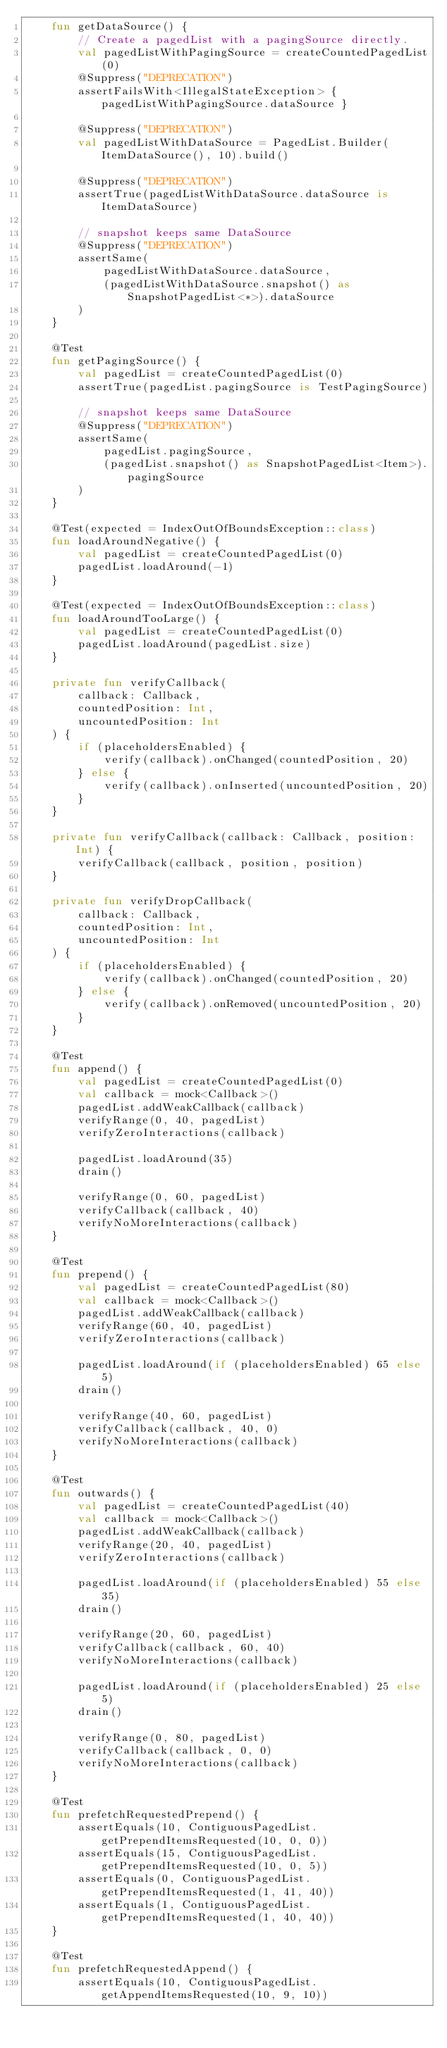<code> <loc_0><loc_0><loc_500><loc_500><_Kotlin_>    fun getDataSource() {
        // Create a pagedList with a pagingSource directly.
        val pagedListWithPagingSource = createCountedPagedList(0)
        @Suppress("DEPRECATION")
        assertFailsWith<IllegalStateException> { pagedListWithPagingSource.dataSource }

        @Suppress("DEPRECATION")
        val pagedListWithDataSource = PagedList.Builder(ItemDataSource(), 10).build()

        @Suppress("DEPRECATION")
        assertTrue(pagedListWithDataSource.dataSource is ItemDataSource)

        // snapshot keeps same DataSource
        @Suppress("DEPRECATION")
        assertSame(
            pagedListWithDataSource.dataSource,
            (pagedListWithDataSource.snapshot() as SnapshotPagedList<*>).dataSource
        )
    }

    @Test
    fun getPagingSource() {
        val pagedList = createCountedPagedList(0)
        assertTrue(pagedList.pagingSource is TestPagingSource)

        // snapshot keeps same DataSource
        @Suppress("DEPRECATION")
        assertSame(
            pagedList.pagingSource,
            (pagedList.snapshot() as SnapshotPagedList<Item>).pagingSource
        )
    }

    @Test(expected = IndexOutOfBoundsException::class)
    fun loadAroundNegative() {
        val pagedList = createCountedPagedList(0)
        pagedList.loadAround(-1)
    }

    @Test(expected = IndexOutOfBoundsException::class)
    fun loadAroundTooLarge() {
        val pagedList = createCountedPagedList(0)
        pagedList.loadAround(pagedList.size)
    }

    private fun verifyCallback(
        callback: Callback,
        countedPosition: Int,
        uncountedPosition: Int
    ) {
        if (placeholdersEnabled) {
            verify(callback).onChanged(countedPosition, 20)
        } else {
            verify(callback).onInserted(uncountedPosition, 20)
        }
    }

    private fun verifyCallback(callback: Callback, position: Int) {
        verifyCallback(callback, position, position)
    }

    private fun verifyDropCallback(
        callback: Callback,
        countedPosition: Int,
        uncountedPosition: Int
    ) {
        if (placeholdersEnabled) {
            verify(callback).onChanged(countedPosition, 20)
        } else {
            verify(callback).onRemoved(uncountedPosition, 20)
        }
    }

    @Test
    fun append() {
        val pagedList = createCountedPagedList(0)
        val callback = mock<Callback>()
        pagedList.addWeakCallback(callback)
        verifyRange(0, 40, pagedList)
        verifyZeroInteractions(callback)

        pagedList.loadAround(35)
        drain()

        verifyRange(0, 60, pagedList)
        verifyCallback(callback, 40)
        verifyNoMoreInteractions(callback)
    }

    @Test
    fun prepend() {
        val pagedList = createCountedPagedList(80)
        val callback = mock<Callback>()
        pagedList.addWeakCallback(callback)
        verifyRange(60, 40, pagedList)
        verifyZeroInteractions(callback)

        pagedList.loadAround(if (placeholdersEnabled) 65 else 5)
        drain()

        verifyRange(40, 60, pagedList)
        verifyCallback(callback, 40, 0)
        verifyNoMoreInteractions(callback)
    }

    @Test
    fun outwards() {
        val pagedList = createCountedPagedList(40)
        val callback = mock<Callback>()
        pagedList.addWeakCallback(callback)
        verifyRange(20, 40, pagedList)
        verifyZeroInteractions(callback)

        pagedList.loadAround(if (placeholdersEnabled) 55 else 35)
        drain()

        verifyRange(20, 60, pagedList)
        verifyCallback(callback, 60, 40)
        verifyNoMoreInteractions(callback)

        pagedList.loadAround(if (placeholdersEnabled) 25 else 5)
        drain()

        verifyRange(0, 80, pagedList)
        verifyCallback(callback, 0, 0)
        verifyNoMoreInteractions(callback)
    }

    @Test
    fun prefetchRequestedPrepend() {
        assertEquals(10, ContiguousPagedList.getPrependItemsRequested(10, 0, 0))
        assertEquals(15, ContiguousPagedList.getPrependItemsRequested(10, 0, 5))
        assertEquals(0, ContiguousPagedList.getPrependItemsRequested(1, 41, 40))
        assertEquals(1, ContiguousPagedList.getPrependItemsRequested(1, 40, 40))
    }

    @Test
    fun prefetchRequestedAppend() {
        assertEquals(10, ContiguousPagedList.getAppendItemsRequested(10, 9, 10))</code> 